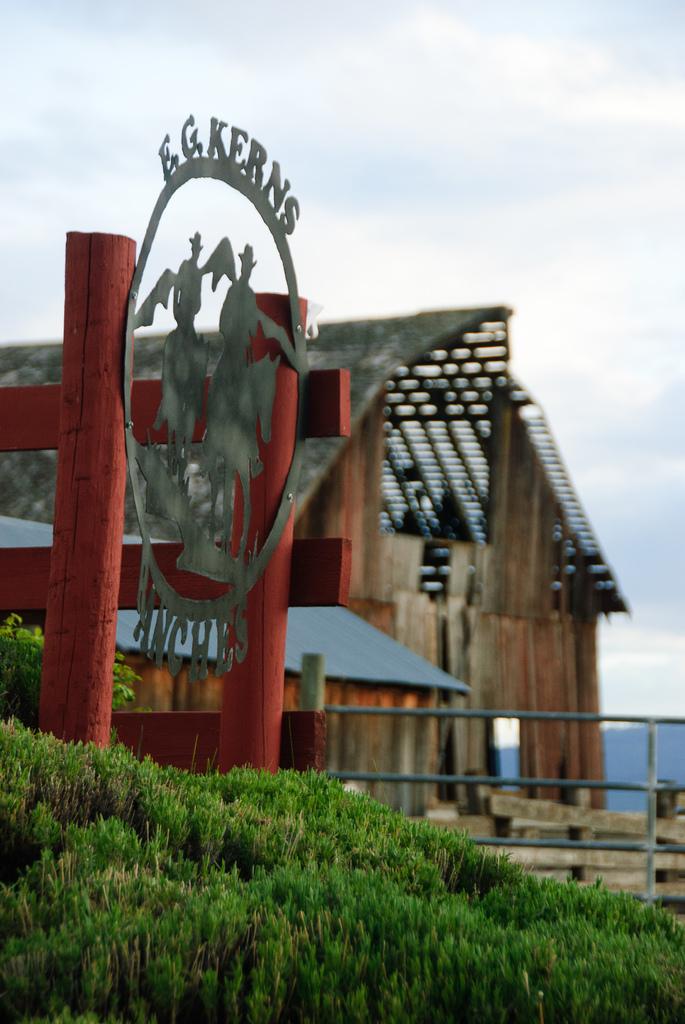What does it say on top of the symbol of two men riding horses?
Give a very brief answer. E.g. kerns. 